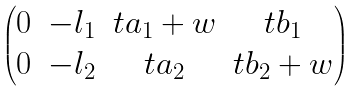Convert formula to latex. <formula><loc_0><loc_0><loc_500><loc_500>\begin{pmatrix} 0 & - l _ { 1 } & t a _ { 1 } + w & t b _ { 1 } \\ 0 & - l _ { 2 } & t a _ { 2 } & t b _ { 2 } + w \end{pmatrix}</formula> 